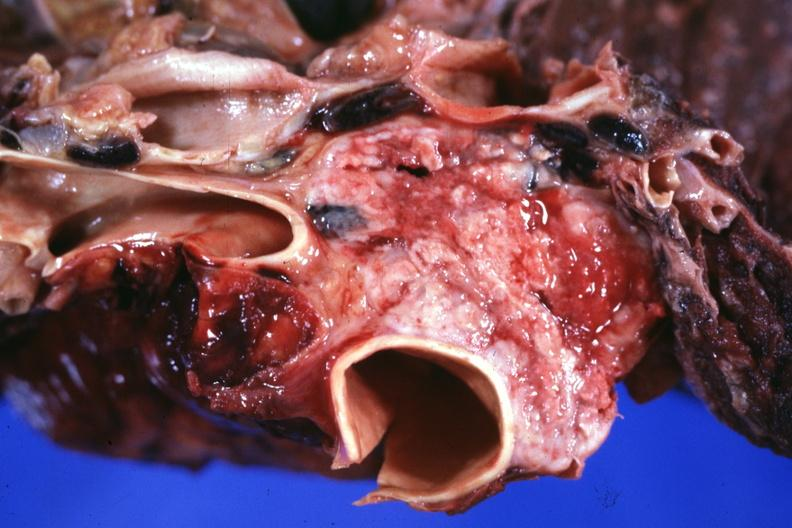what does this image show?
Answer the question using a single word or phrase. Section through mediastinum to show tumor surrounding vessels 